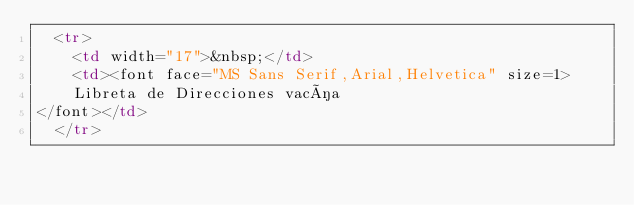<code> <loc_0><loc_0><loc_500><loc_500><_HTML_>  <tr>
    <td width="17">&nbsp;</td>
    <td><font face="MS Sans Serif,Arial,Helvetica" size=1>
	Libreta de Direcciones vacía
</font></td>
  </tr></code> 